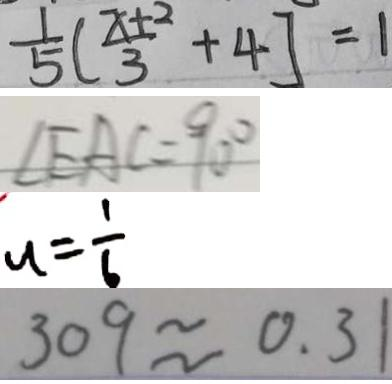Convert formula to latex. <formula><loc_0><loc_0><loc_500><loc_500>\frac { 1 } { 5 } ( \frac { x + 2 } { 3 } + 4 ] = 1 
 \angle E A C = 9 0 ^ { \circ } 
 u = \frac { 1 } { 6 } 
 3 0 9 \approx 0 . 3 1</formula> 